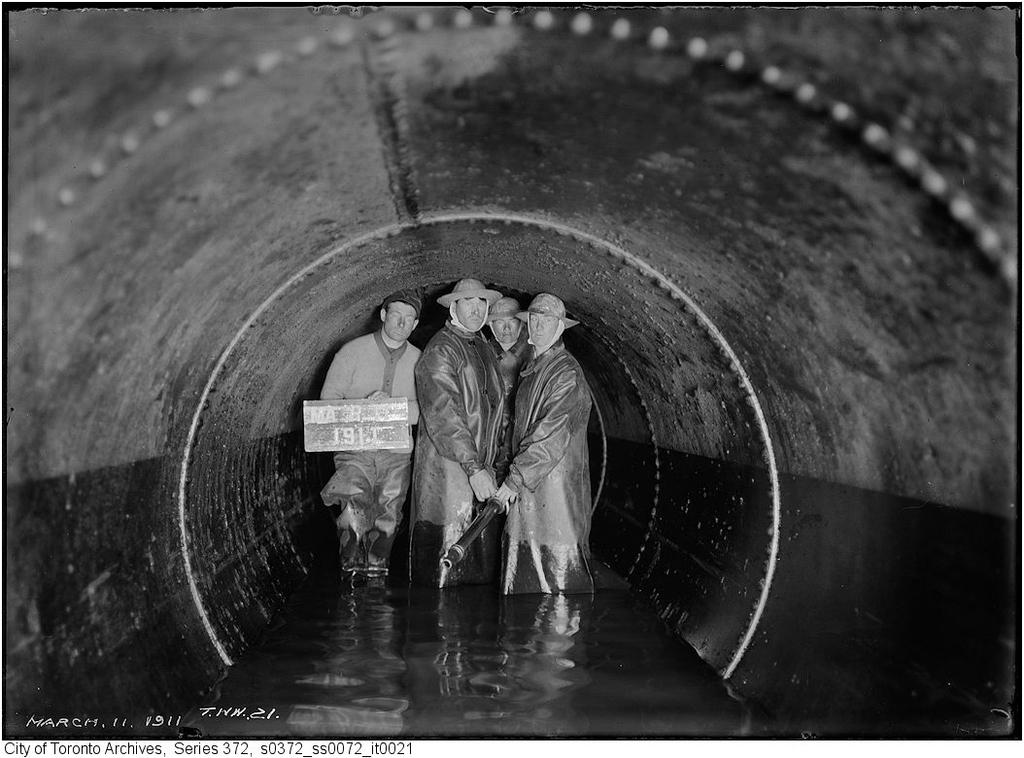What are the men in the image doing? The men in the image are standing in the water. What additional feature can be seen in the image? There is a tunnel in the image. What type of comb is being used by the men in the image? There is no comb present in the image; the men are standing in the water. 